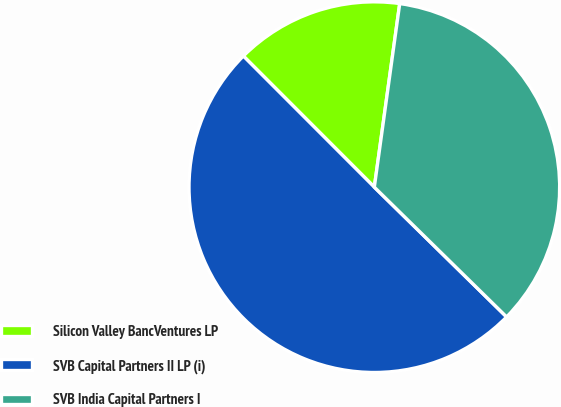Convert chart to OTSL. <chart><loc_0><loc_0><loc_500><loc_500><pie_chart><fcel>Silicon Valley BancVentures LP<fcel>SVB Capital Partners II LP (i)<fcel>SVB India Capital Partners I<nl><fcel>14.68%<fcel>50.16%<fcel>35.16%<nl></chart> 